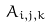<formula> <loc_0><loc_0><loc_500><loc_500>A _ { i , j , k }</formula> 